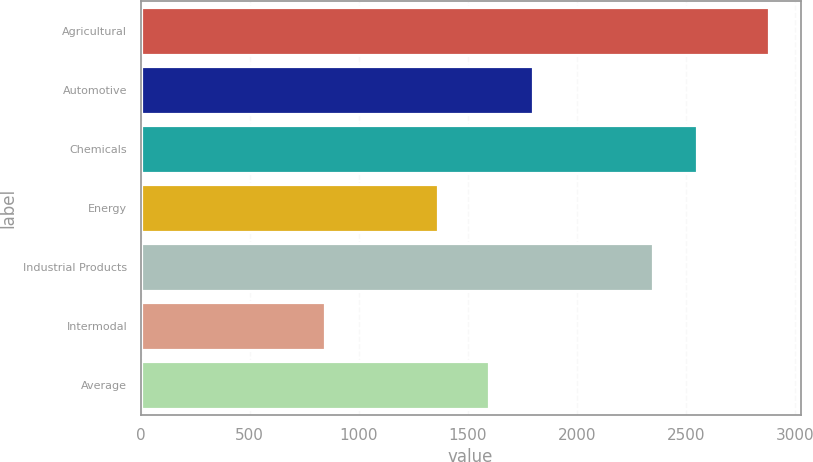<chart> <loc_0><loc_0><loc_500><loc_500><bar_chart><fcel>Agricultural<fcel>Automotive<fcel>Chemicals<fcel>Energy<fcel>Industrial Products<fcel>Intermodal<fcel>Average<nl><fcel>2880<fcel>1797.7<fcel>2550.7<fcel>1364<fcel>2347<fcel>843<fcel>1594<nl></chart> 